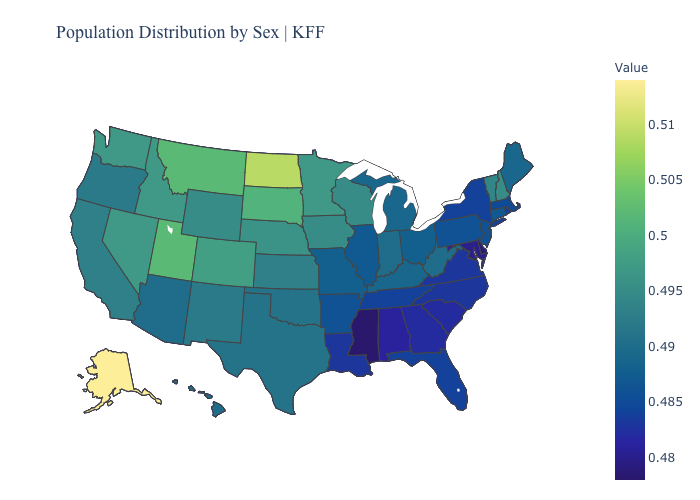Which states have the lowest value in the West?
Concise answer only. Arizona, Hawaii. Among the states that border Texas , which have the lowest value?
Give a very brief answer. Louisiana. Does Mississippi have the lowest value in the USA?
Concise answer only. Yes. Among the states that border Rhode Island , which have the highest value?
Answer briefly. Connecticut. Does the map have missing data?
Answer briefly. No. Which states hav the highest value in the Northeast?
Keep it brief. New Hampshire. Which states have the highest value in the USA?
Write a very short answer. Alaska. 